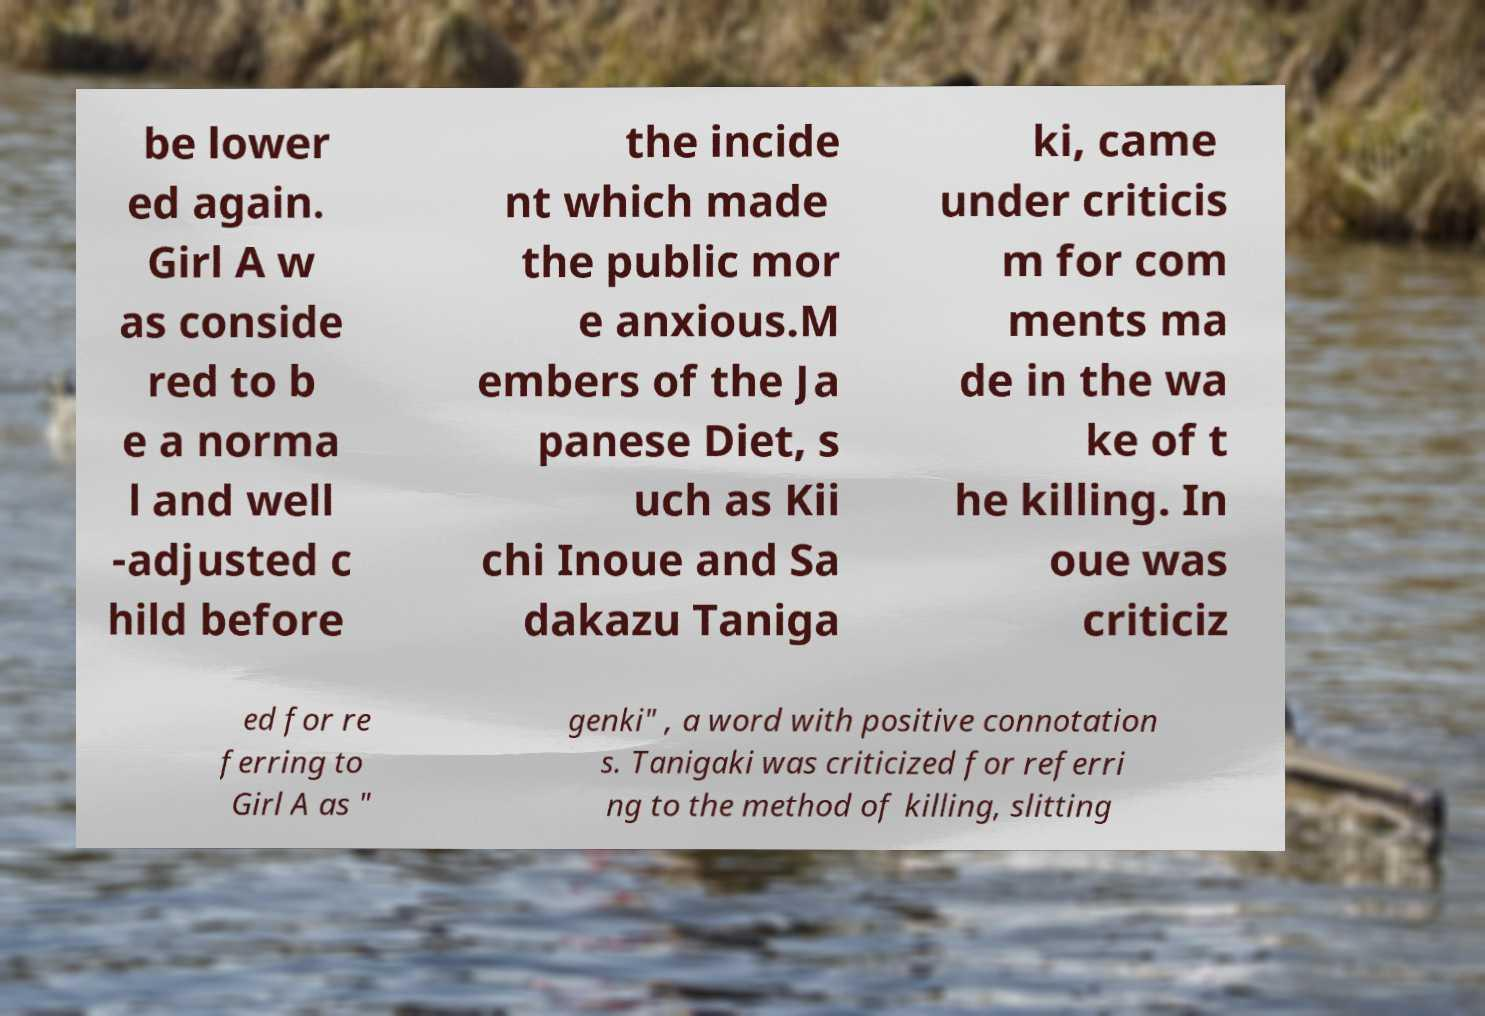Could you extract and type out the text from this image? be lower ed again. Girl A w as conside red to b e a norma l and well -adjusted c hild before the incide nt which made the public mor e anxious.M embers of the Ja panese Diet, s uch as Kii chi Inoue and Sa dakazu Taniga ki, came under criticis m for com ments ma de in the wa ke of t he killing. In oue was criticiz ed for re ferring to Girl A as " genki" , a word with positive connotation s. Tanigaki was criticized for referri ng to the method of killing, slitting 